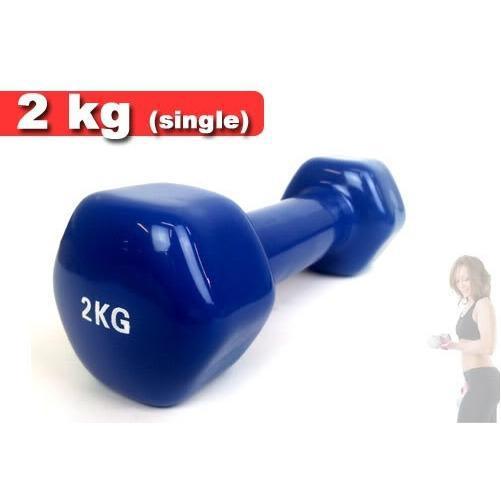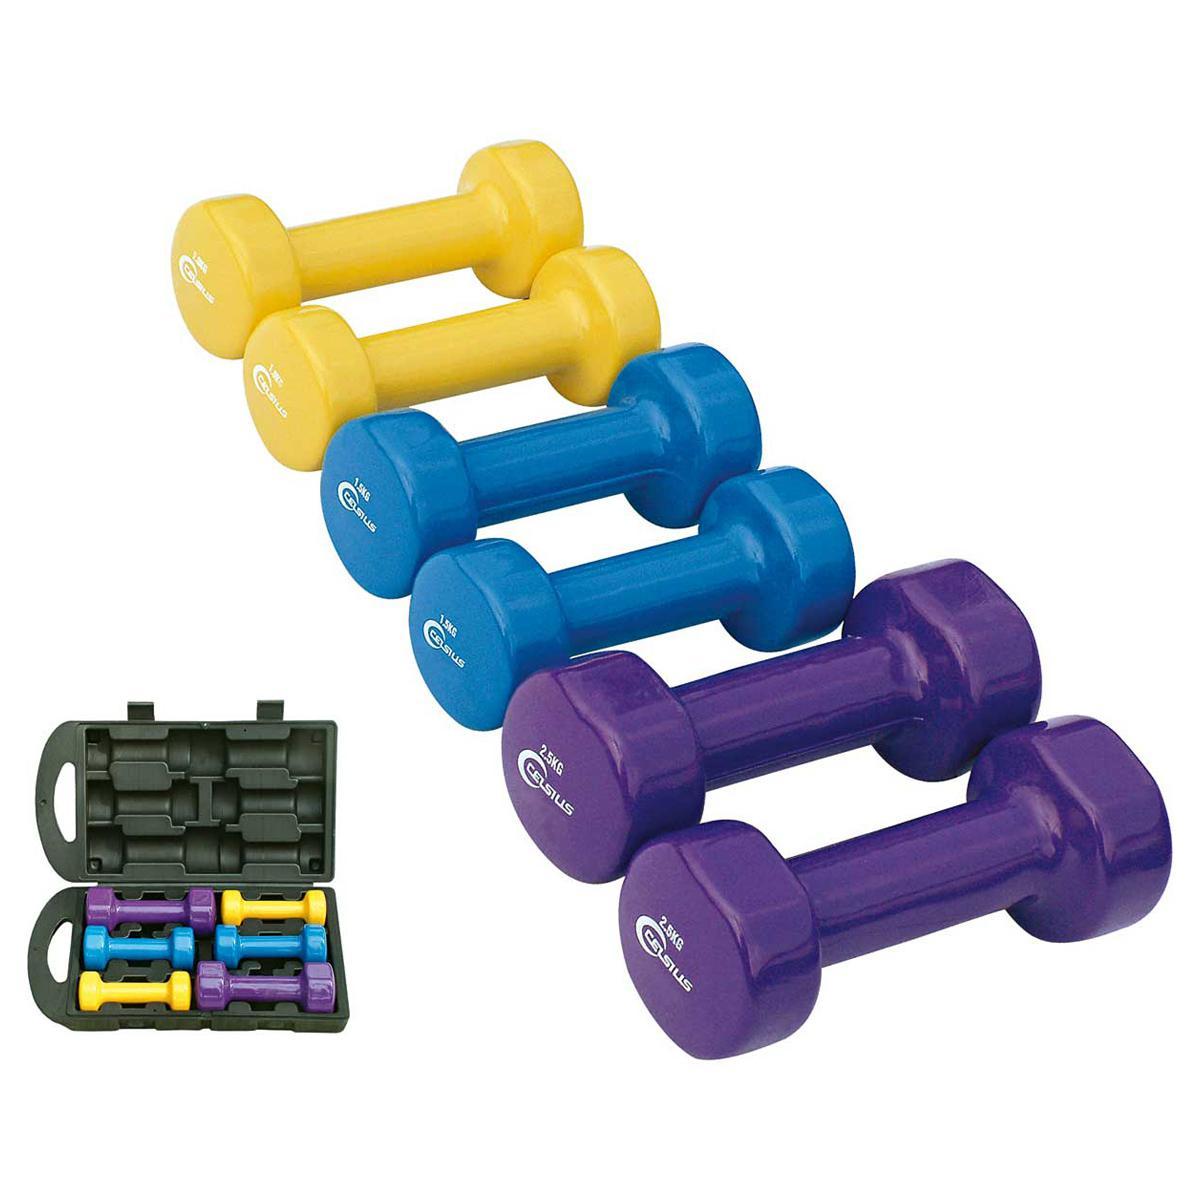The first image is the image on the left, the second image is the image on the right. For the images shown, is this caption "In at least one image there is a total of 12 weights." true? Answer yes or no. Yes. The first image is the image on the left, the second image is the image on the right. For the images displayed, is the sentence "One image features at least 10 different colors of dumbbells." factually correct? Answer yes or no. No. 